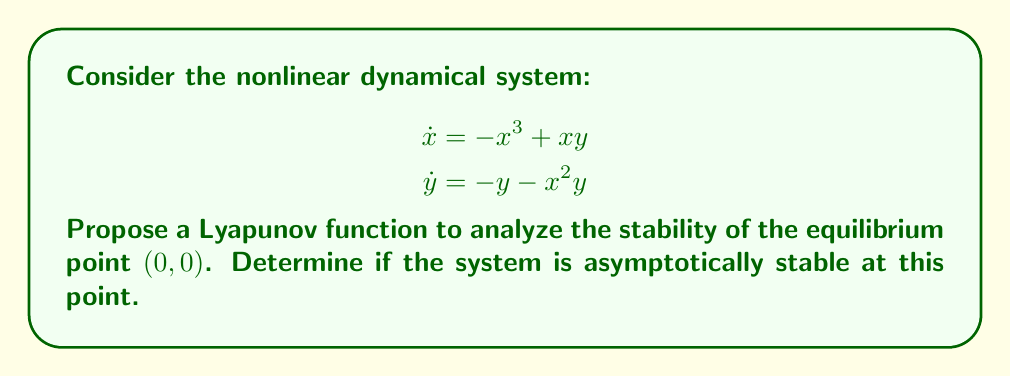Could you help me with this problem? Let's approach this step-by-step:

1) First, we need to propose a Lyapunov function. A good candidate for this system is:

   $V(x,y) = \frac{1}{2}(x^2 + y^2)$

2) To prove stability, we need to show that $V(x,y)$ is positive definite and $\dot{V}(x,y)$ is negative definite in a neighborhood of $(0,0)$.

3) Clearly, $V(x,y) > 0$ for all $(x,y) \neq (0,0)$, and $V(0,0) = 0$. So $V(x,y)$ is positive definite.

4) Now, let's calculate $\dot{V}(x,y)$:

   $$\begin{align}
   \dot{V}(x,y) &= \frac{\partial V}{\partial x}\dot{x} + \frac{\partial V}{\partial y}\dot{y} \\
   &= x\dot{x} + y\dot{y} \\
   &= x(-x^3+xy) + y(-y-x^2y) \\
   &= -x^4 + x^2y - y^2 - x^2y^2 \\
   &= -x^4 - y^2 - x^2y^2
   \end{align}$$

5) We can see that $\dot{V}(x,y) < 0$ for all $(x,y) \neq (0,0)$, and $\dot{V}(0,0) = 0$.

6) Since $V(x,y)$ is positive definite and $\dot{V}(x,y)$ is negative definite in the neighborhood of $(0,0)$, we can conclude that the system is asymptotically stable at the equilibrium point $(0,0)$.

This analysis, free from sensationalism, provides a rigorous mathematical proof of the system's stability, aligning with the critical thinking expected of a mature South African citizen.
Answer: The system is asymptotically stable at $(0,0)$. 